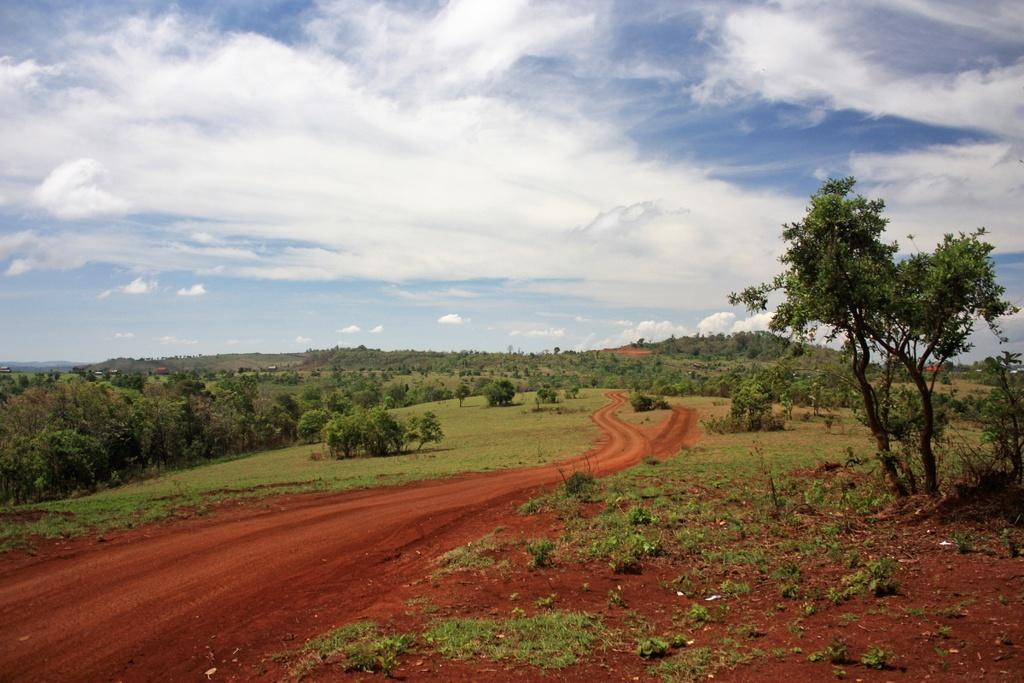What type of vegetation can be seen in the image? There are plants and trees in the image. What type of landscape feature is present in the image? There are hills in the image. What can be seen in the background of the image? The sky is visible in the background of the image. What type of pickle is hanging from the tree in the image? There is no pickle present in the image; there are only plants and trees. 